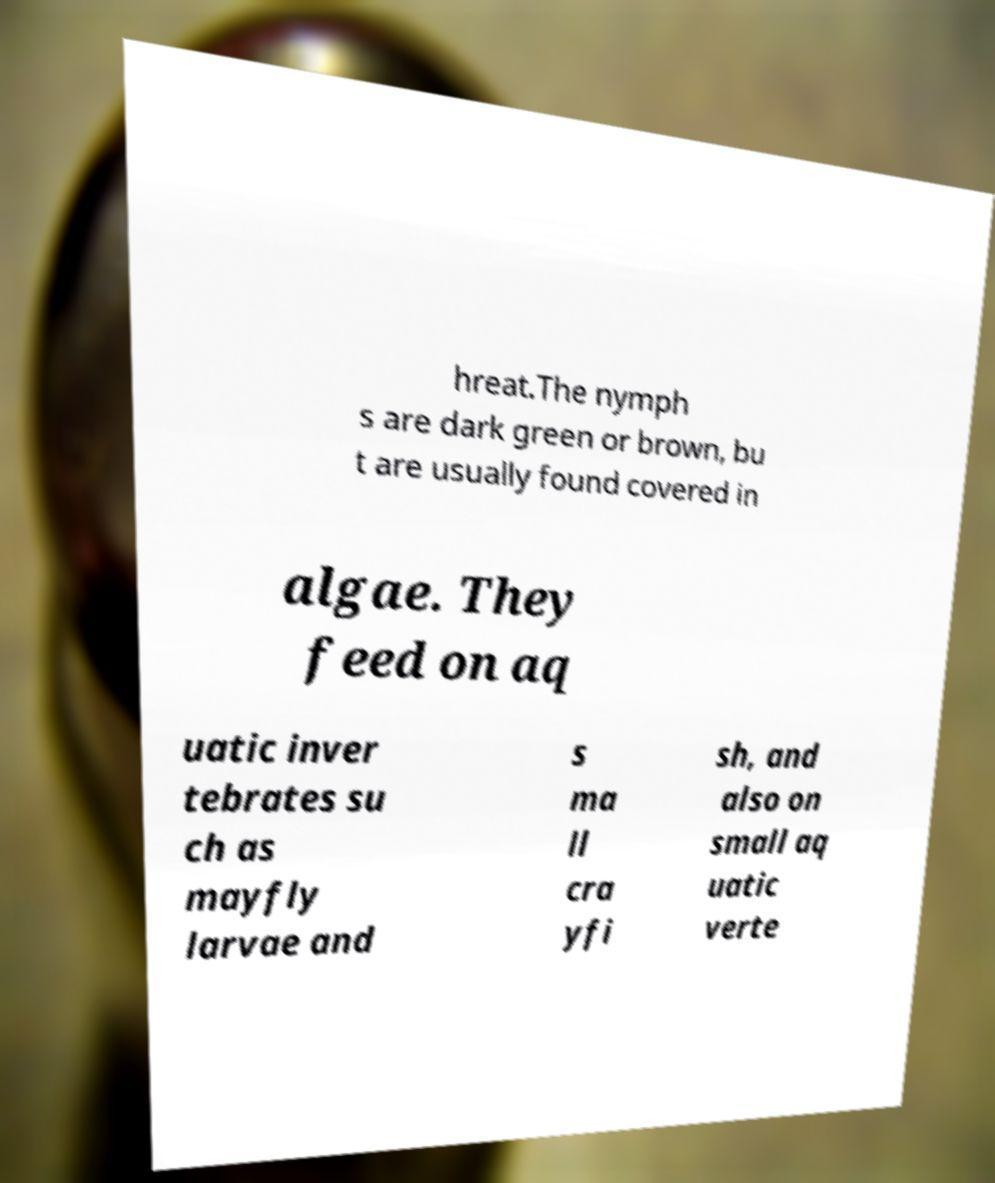Could you assist in decoding the text presented in this image and type it out clearly? hreat.The nymph s are dark green or brown, bu t are usually found covered in algae. They feed on aq uatic inver tebrates su ch as mayfly larvae and s ma ll cra yfi sh, and also on small aq uatic verte 